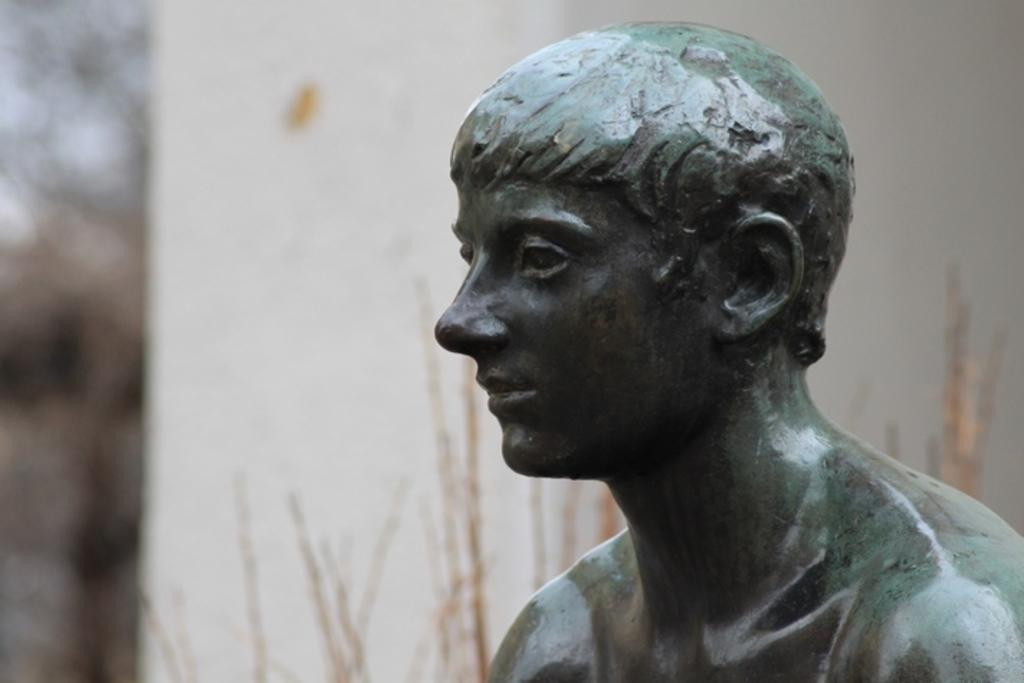What is the main subject in the image? There is a statue in the image. What can be seen behind the statue? There is a wall visible behind the statue. Are there any other elements in the image besides the statue and wall? Yes, there are plants near the wall. What type of knowledge is being shared by the statue in the image? The statue in the image is not sharing any knowledge, as it is a static object and not a living being capable of communication. 